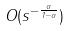<formula> <loc_0><loc_0><loc_500><loc_500>O ( s ^ { - \frac { \alpha } { 1 - \alpha } } )</formula> 